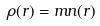Convert formula to latex. <formula><loc_0><loc_0><loc_500><loc_500>\rho ( r ) = m n ( r )</formula> 